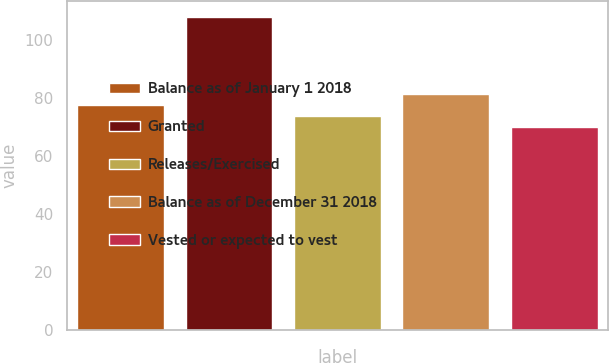Convert chart to OTSL. <chart><loc_0><loc_0><loc_500><loc_500><bar_chart><fcel>Balance as of January 1 2018<fcel>Granted<fcel>Releases/Exercised<fcel>Balance as of December 31 2018<fcel>Vested or expected to vest<nl><fcel>77.6<fcel>108<fcel>73.8<fcel>81.4<fcel>70<nl></chart> 